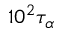<formula> <loc_0><loc_0><loc_500><loc_500>1 0 ^ { 2 } \tau _ { \alpha }</formula> 